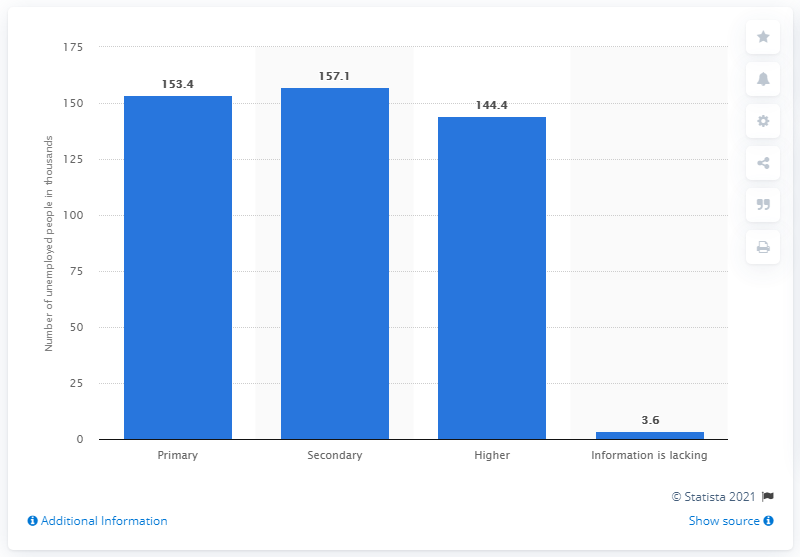Mention a couple of crucial points in this snapshot. In 2020, there were 144,400 unemployed individuals in Sweden who held a higher education. In 2020, there were 157,100 unemployed people in Sweden who had completed secondary education. In 2020, there were 153,400 unemployed individuals in Sweden who had completed primary education. 